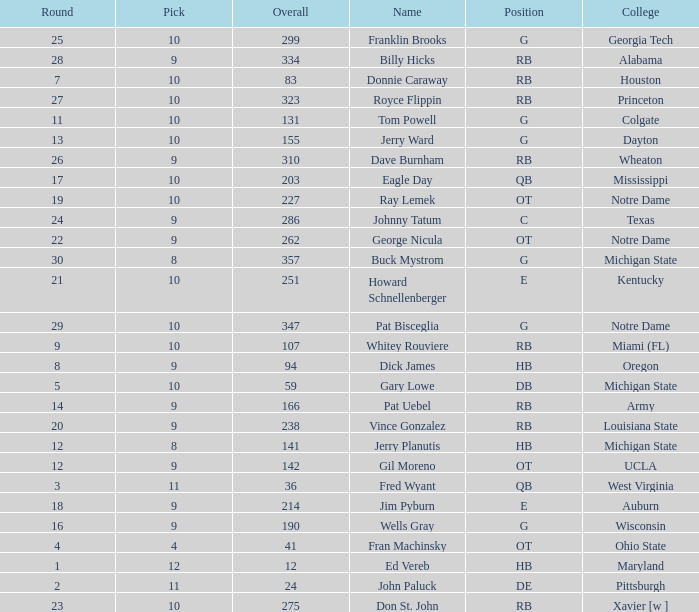What is the highest overall pick number for george nicula who had a pick smaller than 9? None. 